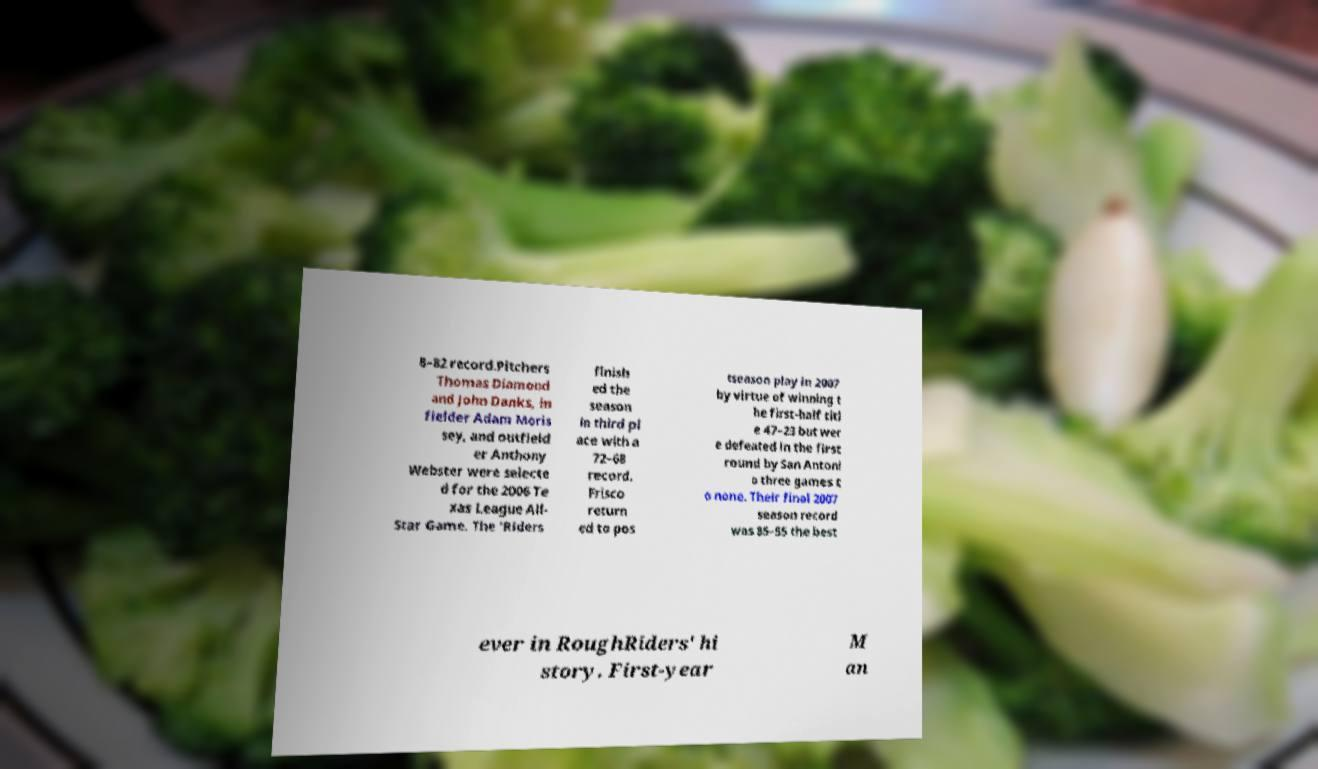Can you read and provide the text displayed in the image?This photo seems to have some interesting text. Can you extract and type it out for me? 8–82 record.Pitchers Thomas Diamond and John Danks, in fielder Adam Moris sey, and outfield er Anthony Webster were selecte d for the 2006 Te xas League All- Star Game. The 'Riders finish ed the season in third pl ace with a 72–68 record. Frisco return ed to pos tseason play in 2007 by virtue of winning t he first-half titl e 47–23 but wer e defeated in the first round by San Antoni o three games t o none. Their final 2007 season record was 85–55 the best ever in RoughRiders' hi story. First-year M an 